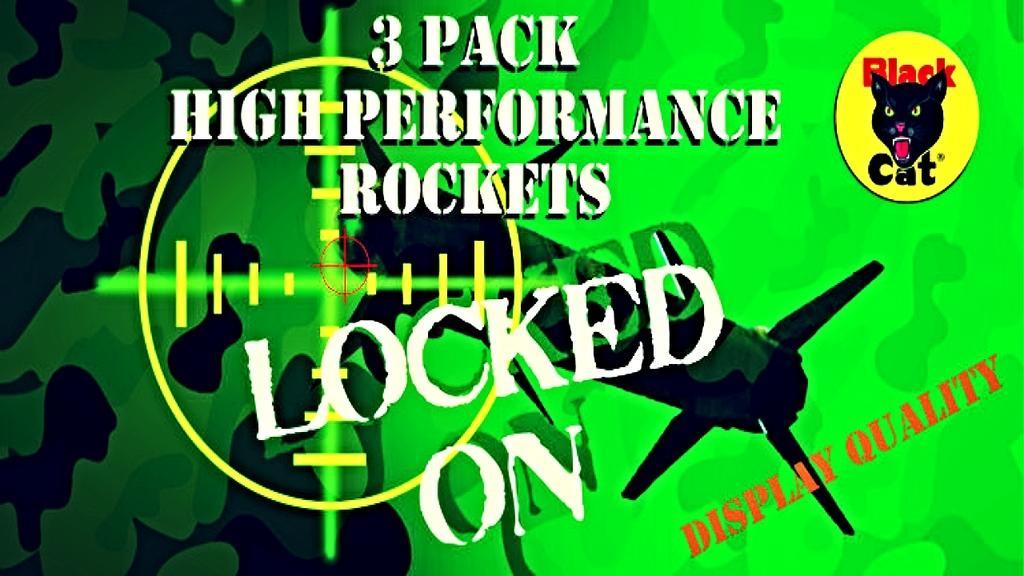Could you give a brief overview of what you see in this image? This image is a depiction. In this image we can see text and cat face. 